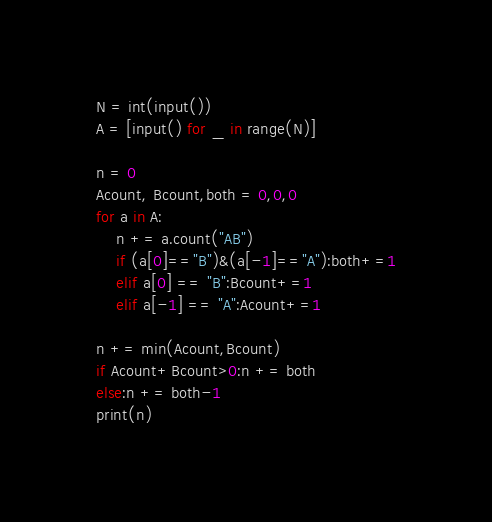<code> <loc_0><loc_0><loc_500><loc_500><_Python_>N = int(input())
A = [input() for _ in range(N)]

n = 0
Acount, Bcount,both = 0,0,0
for a in A:
    n += a.count("AB")
    if (a[0]=="B")&(a[-1]=="A"):both+=1
    elif a[0] == "B":Bcount+=1
    elif a[-1] == "A":Acount+=1

n += min(Acount,Bcount)
if Acount+Bcount>0:n += both
else:n += both-1
print(n)</code> 